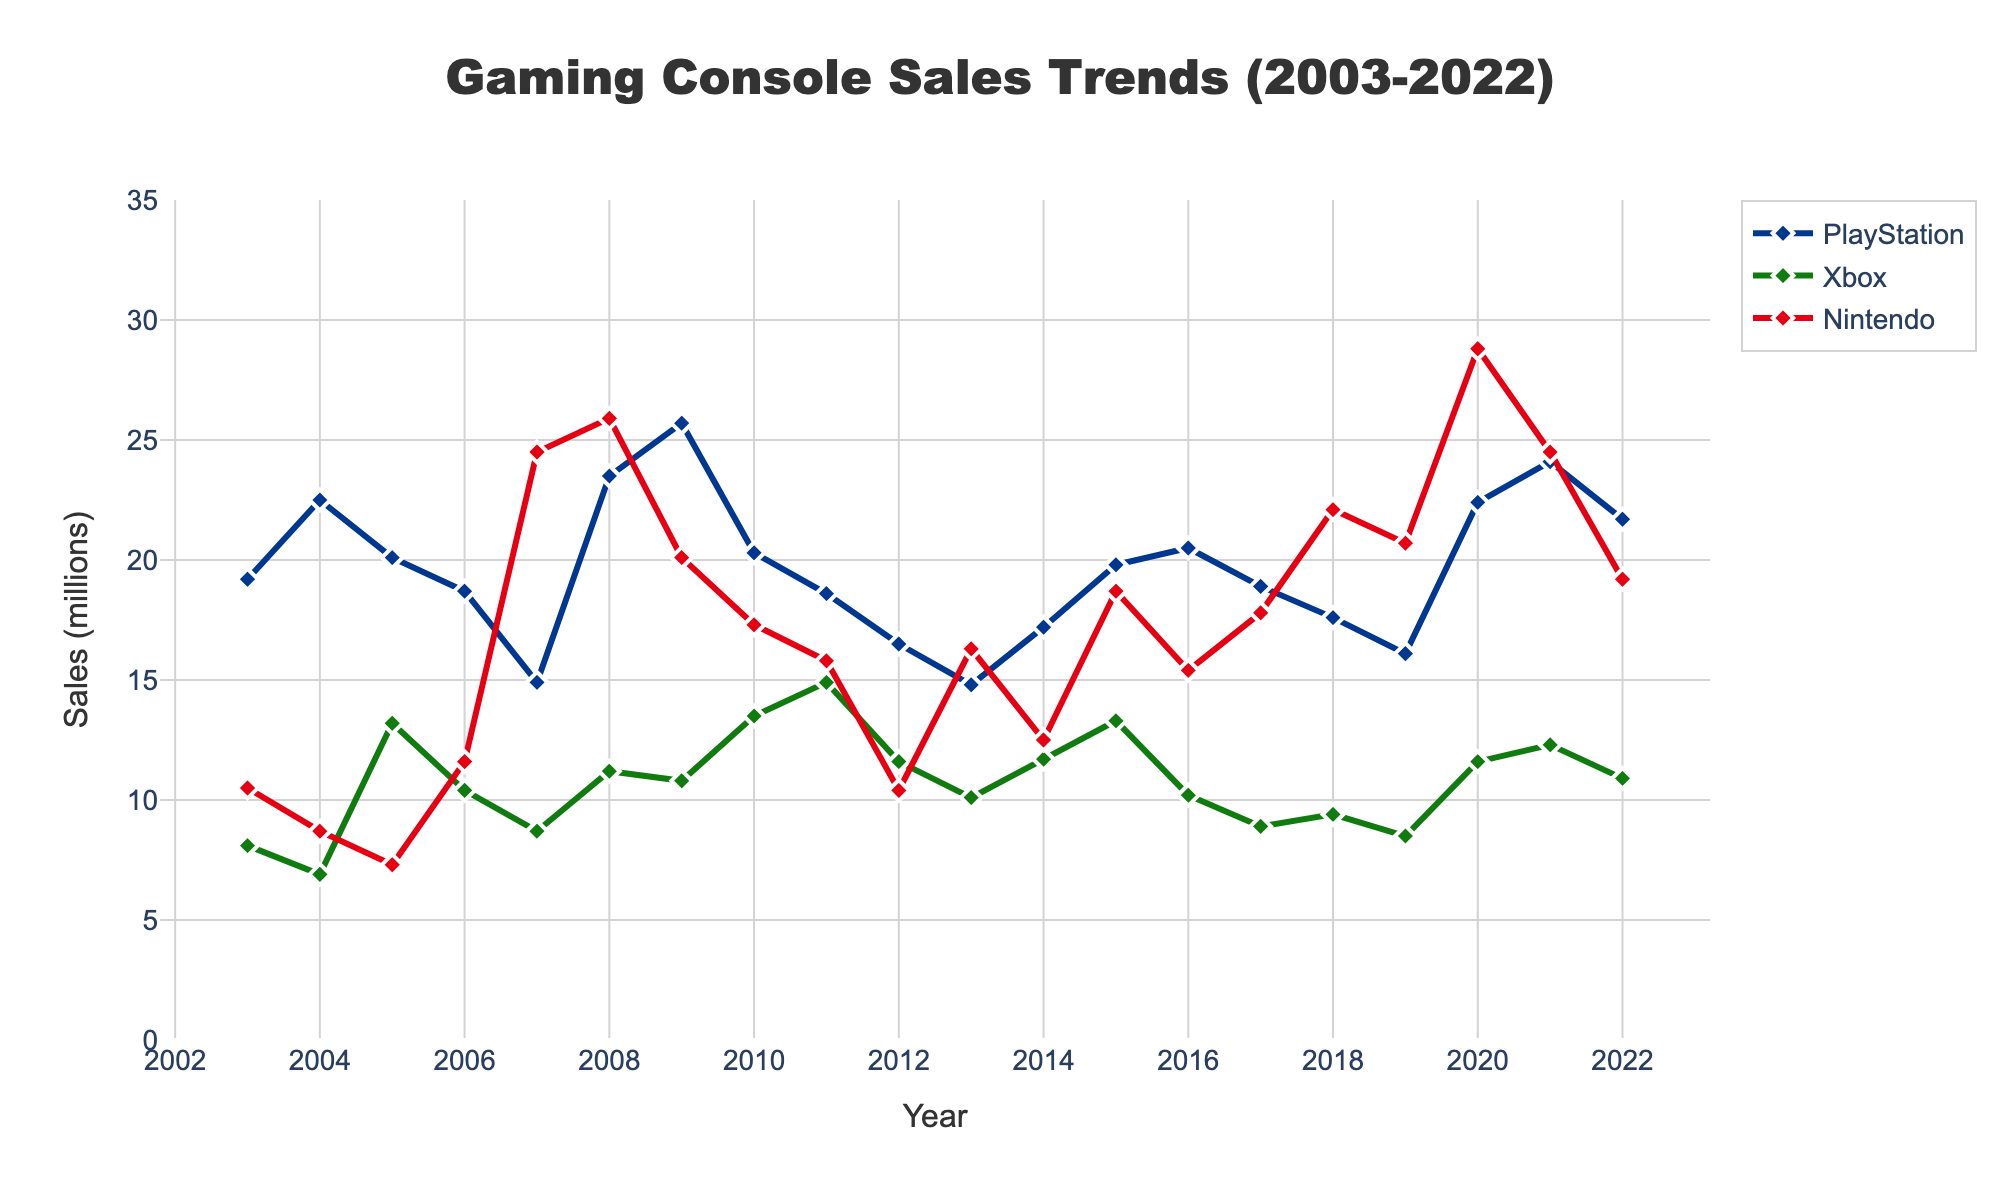Which brand had the highest sales in 2020? To determine this, look at the sales values for each brand in the year 2020. Nintendo shows the highest value with 28.8 million units, compared to PlayStation's 22.4 million units and Xbox's 11.6 million units.
Answer: Nintendo During which year did PlayStation and Nintendo sales both achieve their highest points? Identifying the peak values for each console on the graph, PlayStation's highest sales are in 2021 with 24.1 million units, and Nintendo's peak is in 2020 with 28.8 million units. They do not coincide in the same year. So there's no single year where both had their highest sales.
Answer: No single year What is the difference in sales between Xbox and PlayStation in 2005? In 2005, Xbox sold 13.2 million units, and PlayStation sold 20.1 million units. The difference is computed as 20.1 - 13.2 = 6.9 million units.
Answer: 6.9 million units Which brand had the most consistent sales trend between 2003 and 2022? Consistency in a sales trend can be visually inspected by observing the smoothness and stability of sales lines. Nintendo's sales show considerable fluctuations, while Xbox and PlayStation have more gradual changes. Xbox's line appears somewhat steadier compared to others.
Answer: Xbox In which years did Nintendo outsell both PlayStation and Xbox? Checking the graph visually for the years where Nintendo's sales line is higher than both PlayStation and Xbox, it's clear these years include 2007, 2008, 2009, 2018, 2019, 2020, 2021, and partially 2022.
Answer: 2007, 2008, 2009, 2018, 2019, 2020, 2021, 2022 What year had the greatest difference in sales between the highest-selling and lowest-selling brands? To find the greatest difference, observe each year and calculate the difference between the highest and lowest values. In 2008, the difference is 25.9 (Nintendo) - 6.9 (Xbox) = 19 million units, which is a significant difference.
Answer: 2008 How did Xbox sales in 2011 compare to its sales in 2010? Look at Xbox's sales in 2010 (13.5 million units) and 2011 (14.9 million units). Xbox sales increased in 2011 compared to 2010.
Answer: Increased What is the average sales of PlayStation from 2003 to 2022? Calculate the average by summing the PlayStation sales across all years (total = 384.4) and then dividing by the number of years (20). Average = 384.4 / 20 = 19.22 million units.
Answer: 19.22 million units Which brand had the lowest sales in any single year, and what was the value? Visually inspect the chart to identify the lowest single point among all brands. Xbox had the lowest in 2004 with 6.9 million units.
Answer: Xbox, 6.9 million units 